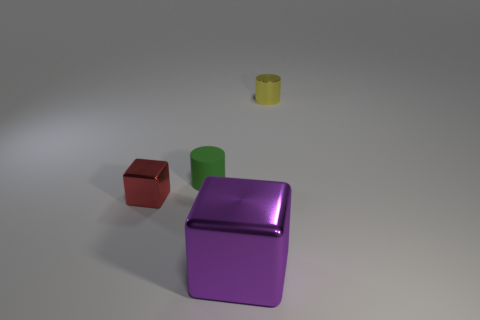Subtract 2 cylinders. How many cylinders are left? 0 Add 4 tiny gray metal cylinders. How many objects exist? 8 Subtract all red cylinders. Subtract all brown cubes. How many cylinders are left? 2 Subtract all cyan spheres. How many yellow cylinders are left? 1 Subtract all yellow things. Subtract all tiny brown metallic spheres. How many objects are left? 3 Add 4 cylinders. How many cylinders are left? 6 Add 2 big red matte objects. How many big red matte objects exist? 2 Subtract 0 cyan blocks. How many objects are left? 4 